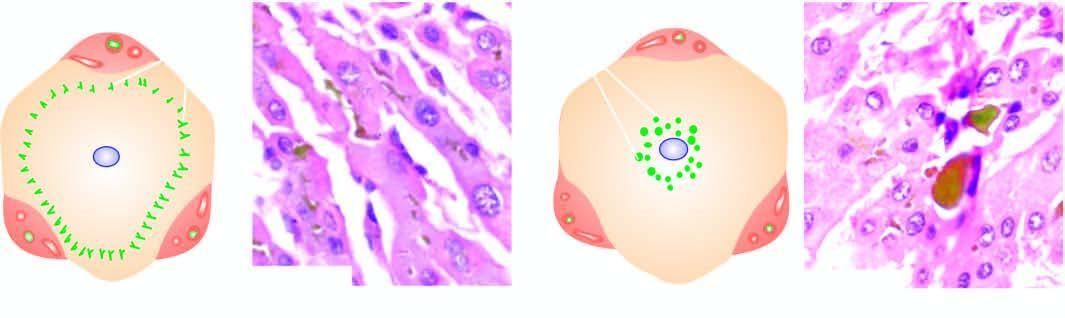what shows characteristic bile lakes due to rupture of canaliculi in the hepatocytes in the centrilobular area?
Answer the question using a single word or phrase. Extrahepatic cholestasis 